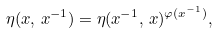<formula> <loc_0><loc_0><loc_500><loc_500>\eta ( x , \, x ^ { - 1 } ) = \eta ( x ^ { - 1 } , \, x ) ^ { \varphi ( x ^ { - 1 } ) } ,</formula> 